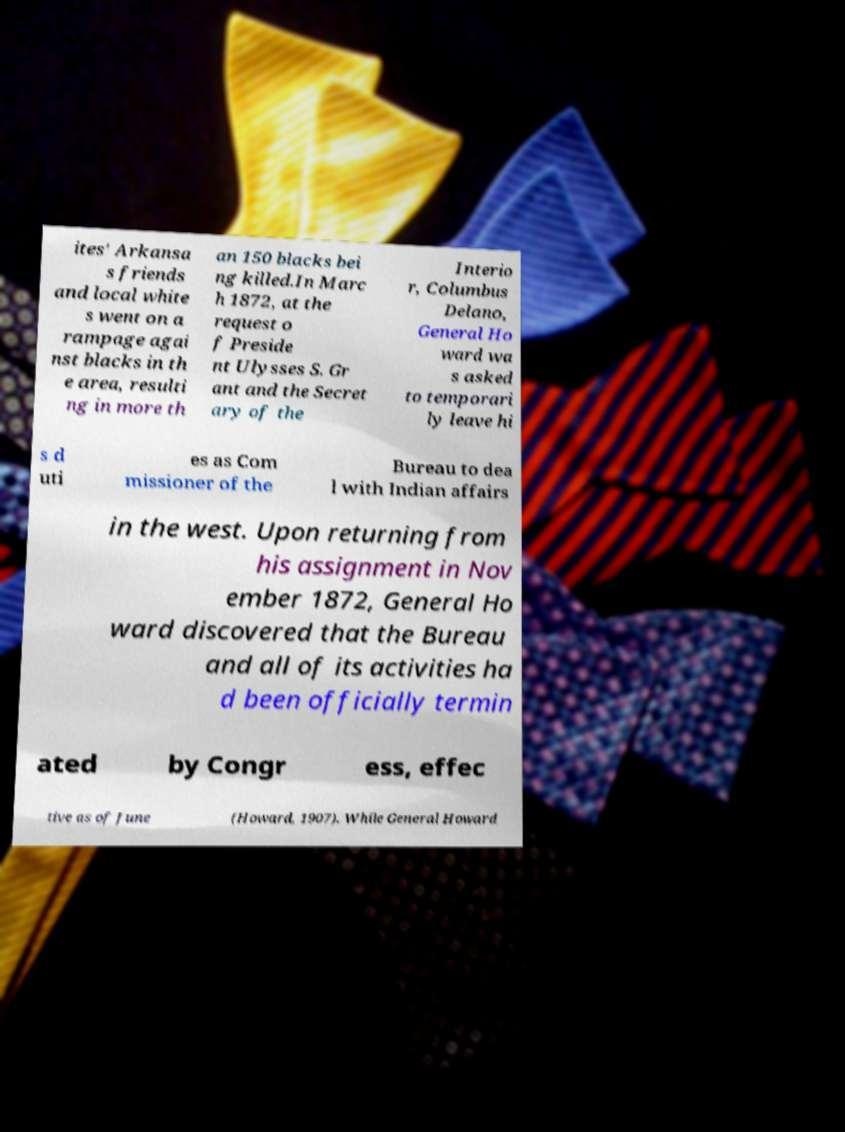I need the written content from this picture converted into text. Can you do that? ites' Arkansa s friends and local white s went on a rampage agai nst blacks in th e area, resulti ng in more th an 150 blacks bei ng killed.In Marc h 1872, at the request o f Preside nt Ulysses S. Gr ant and the Secret ary of the Interio r, Columbus Delano, General Ho ward wa s asked to temporari ly leave hi s d uti es as Com missioner of the Bureau to dea l with Indian affairs in the west. Upon returning from his assignment in Nov ember 1872, General Ho ward discovered that the Bureau and all of its activities ha d been officially termin ated by Congr ess, effec tive as of June (Howard, 1907). While General Howard 